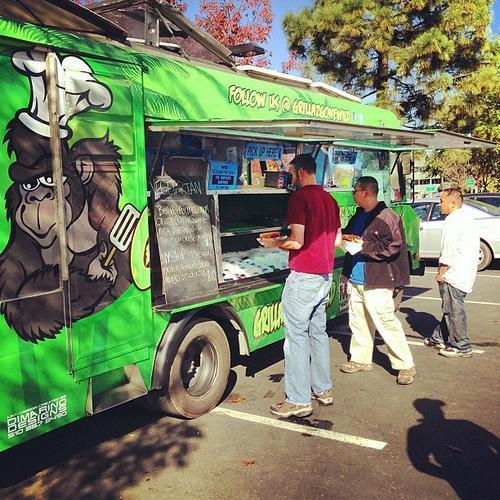How many men are holding plates of food?
Give a very brief answer. 2. 